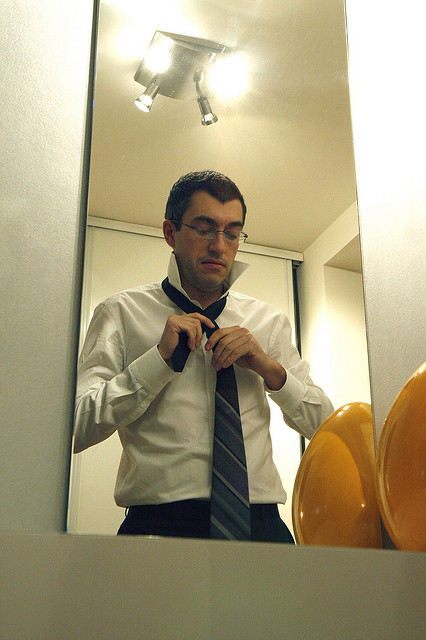Are there any other objects or features near the man besides the mirror and the lightbulbs? Apart from the mirror and the lightbulbs, there aren't any other significant objects or features near the man. The focus remains on his meticulous act of adjusting his necktie, highlighting the simplicity and functionality of the space. 